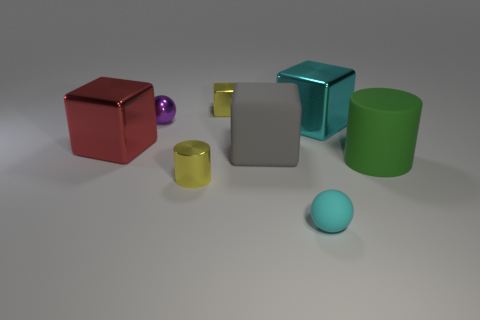What is the size of the block that is the same color as the small cylinder?
Keep it short and to the point. Small. How many small metallic cubes are the same color as the tiny cylinder?
Give a very brief answer. 1. There is a gray block that is the same material as the big green cylinder; what is its size?
Your answer should be very brief. Large. How many objects are tiny objects or rubber balls?
Provide a succinct answer. 4. There is a tiny object that is to the right of the big gray thing; what color is it?
Provide a short and direct response. Cyan. There is a gray matte thing that is the same shape as the large red metal thing; what size is it?
Provide a short and direct response. Large. How many objects are either tiny spheres to the left of the small cyan thing or green objects that are in front of the cyan metal object?
Provide a succinct answer. 2. There is a cube that is in front of the big cyan metal cube and left of the big gray matte thing; what size is it?
Your answer should be compact. Large. Does the tiny purple shiny object have the same shape as the cyan object on the left side of the cyan metal thing?
Your answer should be very brief. Yes. What number of objects are yellow things that are in front of the green cylinder or green metal cubes?
Offer a very short reply. 1. 